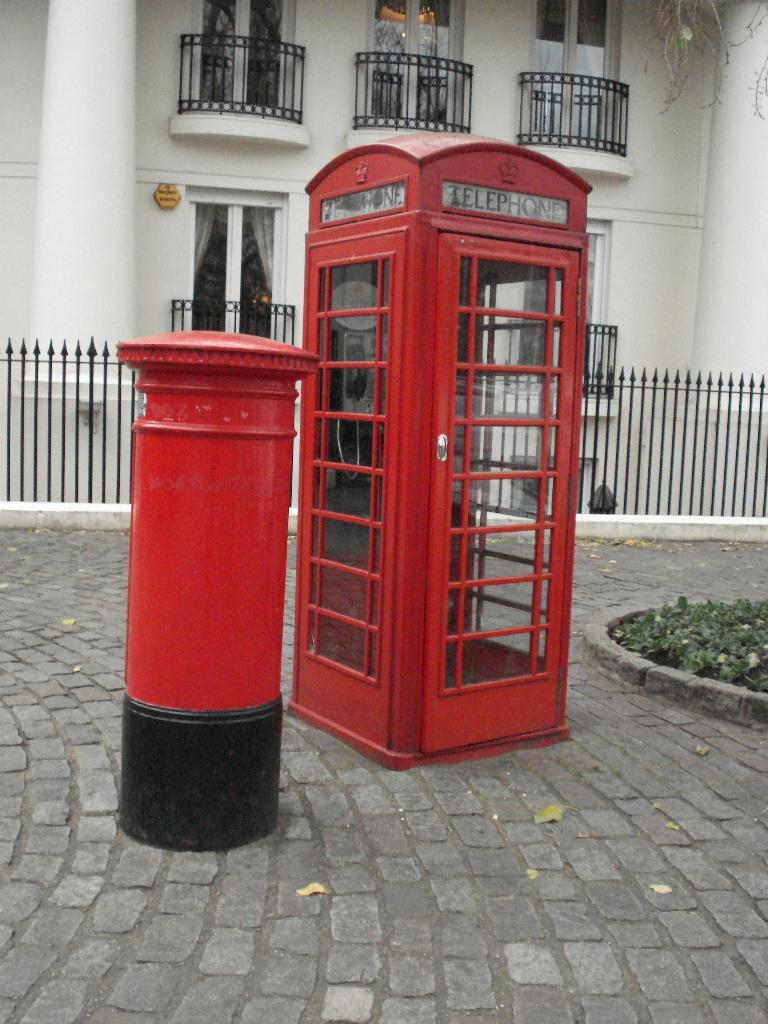Provide a one-sentence caption for the provided image. A red phone booth has a sign that says telephone on it. 